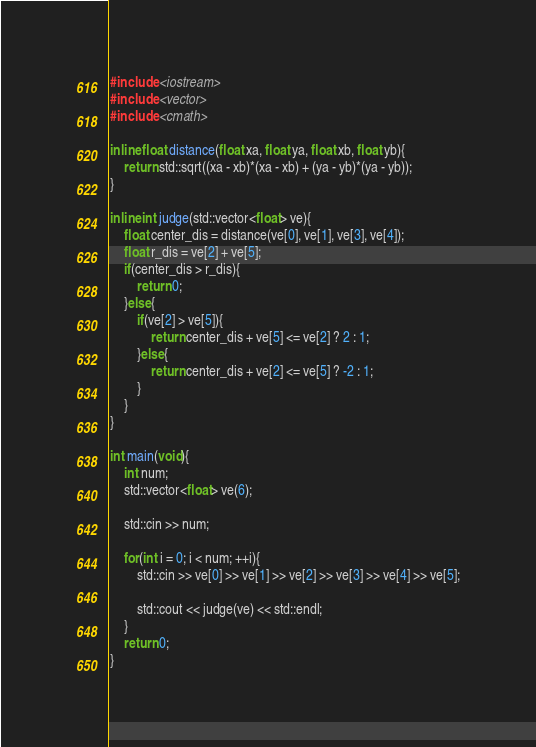<code> <loc_0><loc_0><loc_500><loc_500><_C++_>#include <iostream>
#include <vector>
#include <cmath>

inline float distance(float xa, float ya, float xb, float yb){
	return std::sqrt((xa - xb)*(xa - xb) + (ya - yb)*(ya - yb));
}

inline int judge(std::vector<float> ve){
	float center_dis = distance(ve[0], ve[1], ve[3], ve[4]);
	float r_dis = ve[2] + ve[5];
	if(center_dis > r_dis){
		return 0;	
	}else{
		if(ve[2] > ve[5]){
			return center_dis + ve[5] <= ve[2] ? 2 : 1;
		}else{
			return center_dis + ve[2] <= ve[5] ? -2 : 1;
		}
	}
}

int main(void){
	int num;
	std::vector<float> ve(6);

	std::cin >> num;

	for(int i = 0; i < num; ++i){
		std::cin >> ve[0] >> ve[1] >> ve[2] >> ve[3] >> ve[4] >> ve[5];
		
		std::cout << judge(ve) << std::endl;
	}
	return 0;
}</code> 